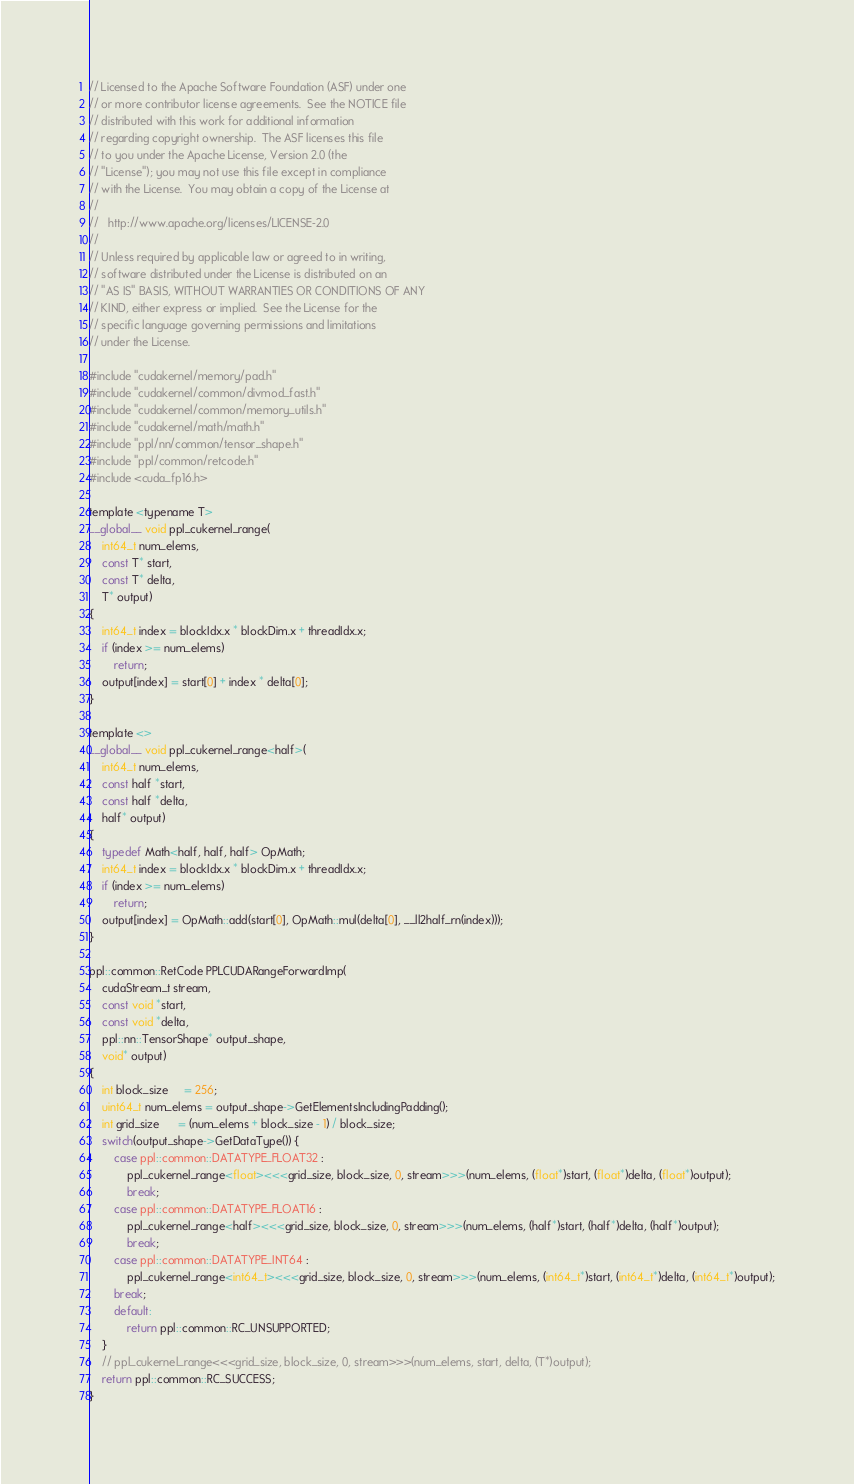<code> <loc_0><loc_0><loc_500><loc_500><_Cuda_>// Licensed to the Apache Software Foundation (ASF) under one
// or more contributor license agreements.  See the NOTICE file
// distributed with this work for additional information
// regarding copyright ownership.  The ASF licenses this file
// to you under the Apache License, Version 2.0 (the
// "License"); you may not use this file except in compliance
// with the License.  You may obtain a copy of the License at
//
//   http://www.apache.org/licenses/LICENSE-2.0
//
// Unless required by applicable law or agreed to in writing,
// software distributed under the License is distributed on an
// "AS IS" BASIS, WITHOUT WARRANTIES OR CONDITIONS OF ANY
// KIND, either express or implied.  See the License for the
// specific language governing permissions and limitations
// under the License.

#include "cudakernel/memory/pad.h"
#include "cudakernel/common/divmod_fast.h"
#include "cudakernel/common/memory_utils.h"
#include "cudakernel/math/math.h"
#include "ppl/nn/common/tensor_shape.h"
#include "ppl/common/retcode.h"
#include <cuda_fp16.h>

template <typename T>
__global__ void ppl_cukernel_range(
    int64_t num_elems,
    const T* start,
    const T* delta,
    T* output)
{
    int64_t index = blockIdx.x * blockDim.x + threadIdx.x;
    if (index >= num_elems)
        return;
    output[index] = start[0] + index * delta[0];
}

template <>
__global__ void ppl_cukernel_range<half>(
    int64_t num_elems,
    const half *start,
    const half *delta,
    half* output)
{
    typedef Math<half, half, half> OpMath;
    int64_t index = blockIdx.x * blockDim.x + threadIdx.x;
    if (index >= num_elems)
        return;
    output[index] = OpMath::add(start[0], OpMath::mul(delta[0], __ll2half_rn(index)));
}

ppl::common::RetCode PPLCUDARangeForwardImp(
    cudaStream_t stream,
    const void *start,
    const void *delta,
    ppl::nn::TensorShape* output_shape,
    void* output)
{
    int block_size     = 256;
    uint64_t num_elems = output_shape->GetElementsIncludingPadding();
    int grid_size      = (num_elems + block_size - 1) / block_size;
    switch(output_shape->GetDataType()) {
        case ppl::common::DATATYPE_FLOAT32 :
            ppl_cukernel_range<float><<<grid_size, block_size, 0, stream>>>(num_elems, (float*)start, (float*)delta, (float*)output);
            break;
        case ppl::common::DATATYPE_FLOAT16 :
            ppl_cukernel_range<half><<<grid_size, block_size, 0, stream>>>(num_elems, (half*)start, (half*)delta, (half*)output);
            break;
        case ppl::common::DATATYPE_INT64 :
            ppl_cukernel_range<int64_t><<<grid_size, block_size, 0, stream>>>(num_elems, (int64_t*)start, (int64_t*)delta, (int64_t*)output);
        break;
        default:
            return ppl::common::RC_UNSUPPORTED;
    }
    // ppl_cukernel_range<<<grid_size, block_size, 0, stream>>>(num_elems, start, delta, (T*)output);
    return ppl::common::RC_SUCCESS;
}
</code> 